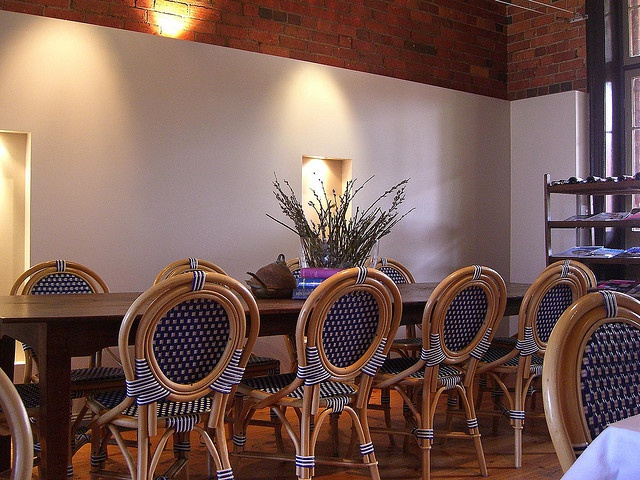Describe the objects in this image and their specific colors. I can see chair in maroon, black, and gray tones, chair in maroon, black, and brown tones, chair in maroon, black, and gray tones, dining table in maroon, black, and brown tones, and chair in maroon, black, and gray tones in this image. 